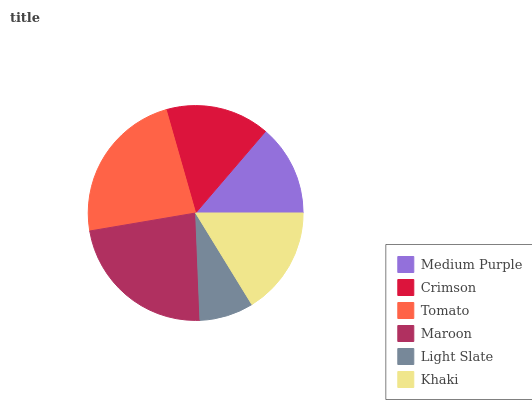Is Light Slate the minimum?
Answer yes or no. Yes. Is Tomato the maximum?
Answer yes or no. Yes. Is Crimson the minimum?
Answer yes or no. No. Is Crimson the maximum?
Answer yes or no. No. Is Crimson greater than Medium Purple?
Answer yes or no. Yes. Is Medium Purple less than Crimson?
Answer yes or no. Yes. Is Medium Purple greater than Crimson?
Answer yes or no. No. Is Crimson less than Medium Purple?
Answer yes or no. No. Is Khaki the high median?
Answer yes or no. Yes. Is Crimson the low median?
Answer yes or no. Yes. Is Tomato the high median?
Answer yes or no. No. Is Light Slate the low median?
Answer yes or no. No. 